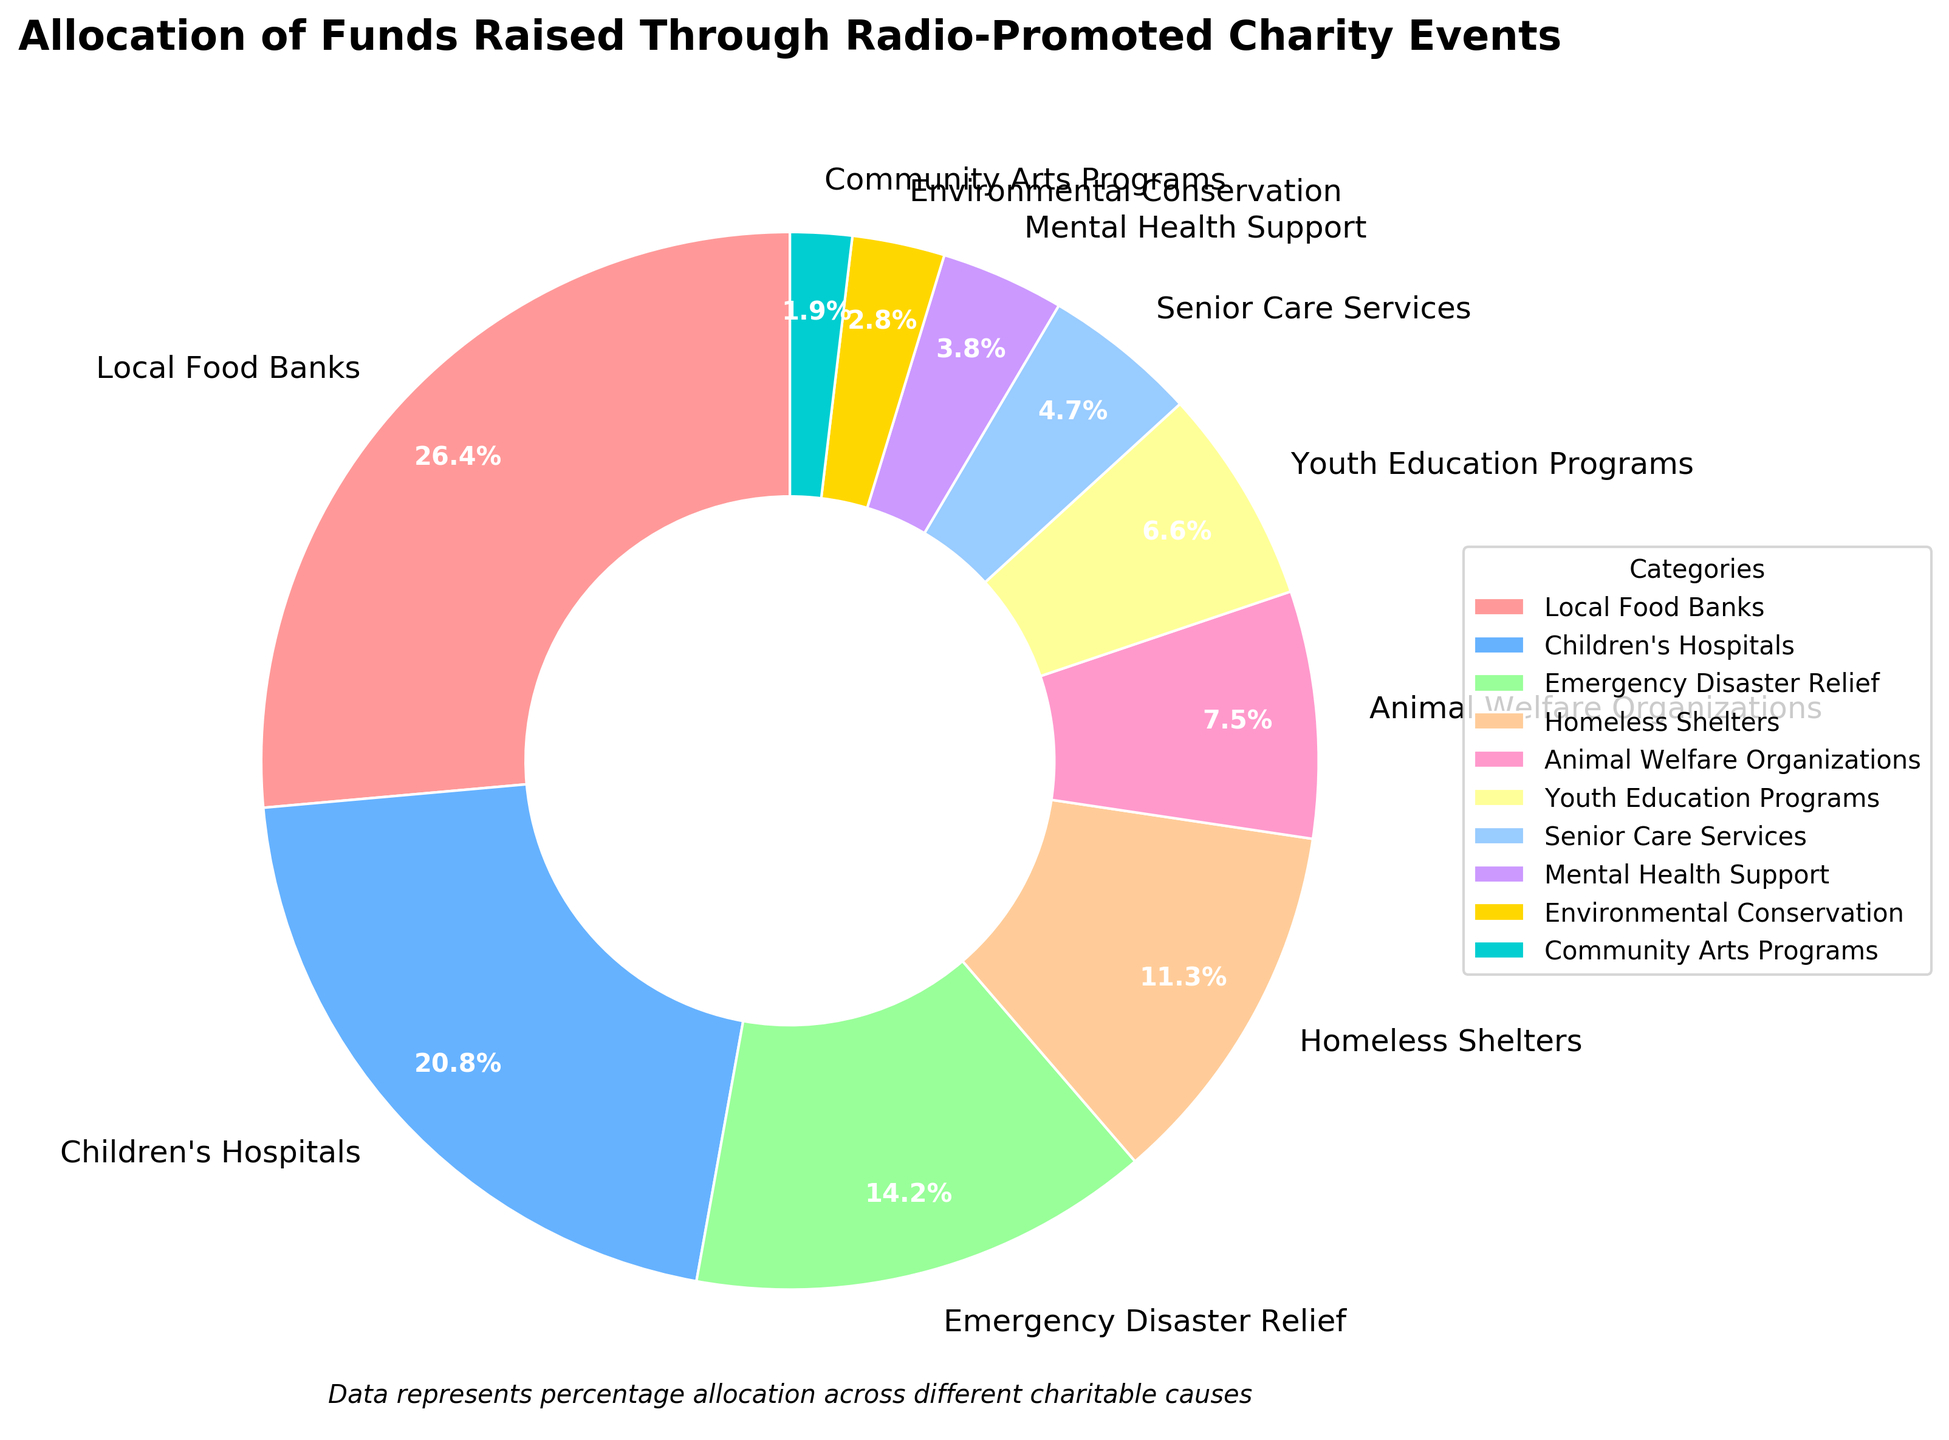What is the largest allocation category? The pie chart shows that the category with the largest segment is Local Food Banks.
Answer: Local Food Banks What is the combined percentage for Local Food Banks and Children's Hospitals? Local Food Banks have 28% and Children's Hospitals have 22%, so their combined percentage is 28% + 22% = 50%.
Answer: 50% Which category has a higher percentage allocation, Homeless Shelters or Animal Welfare Organizations? The pie chart shows Homeless Shelters have 12% and Animal Welfare Organizations have 8%, so Homeless Shelters have a higher percentage allocation.
Answer: Homeless Shelters How much more is allocated to Emergency Disaster Relief compared to Youth Education Programs? Emergency Disaster Relief has 15% and Youth Education Programs have 7%. The difference is 15% - 7% = 8%.
Answer: 8% What is the smallest allocation category? The pie chart shows that the smallest segment is Community Arts Programs with 2%.
Answer: Community Arts Programs Which two categories have a total allocation of 9%? Mental Health Support has 4% and Environmental Conservation has 3%. Their total is 4% + 3% = 7%, which does not meet the requirement. Adding Senior Care Services (5%), we get 5% + 4% = 9%.
Answer: Senior Care Services and Mental Health Support Are there any categories with equal allocation percentages? By examining the pie chart, it's clear that no two categories have the same percentage allocation.
Answer: No What is the difference in percentage points between Children's Hospitals and Senior Care Services? Children's Hospitals have 22% and Senior Care Services have 5%. The difference is 22% - 5% = 17%.
Answer: 17% Which category receives a similar allocation to Children's Hospitals but slightly less? The pie chart shows Emergency Disaster Relief has 15%, which is slightly less than the 22% allocated to Children's Hospitals.
Answer: Emergency Disaster Relief 